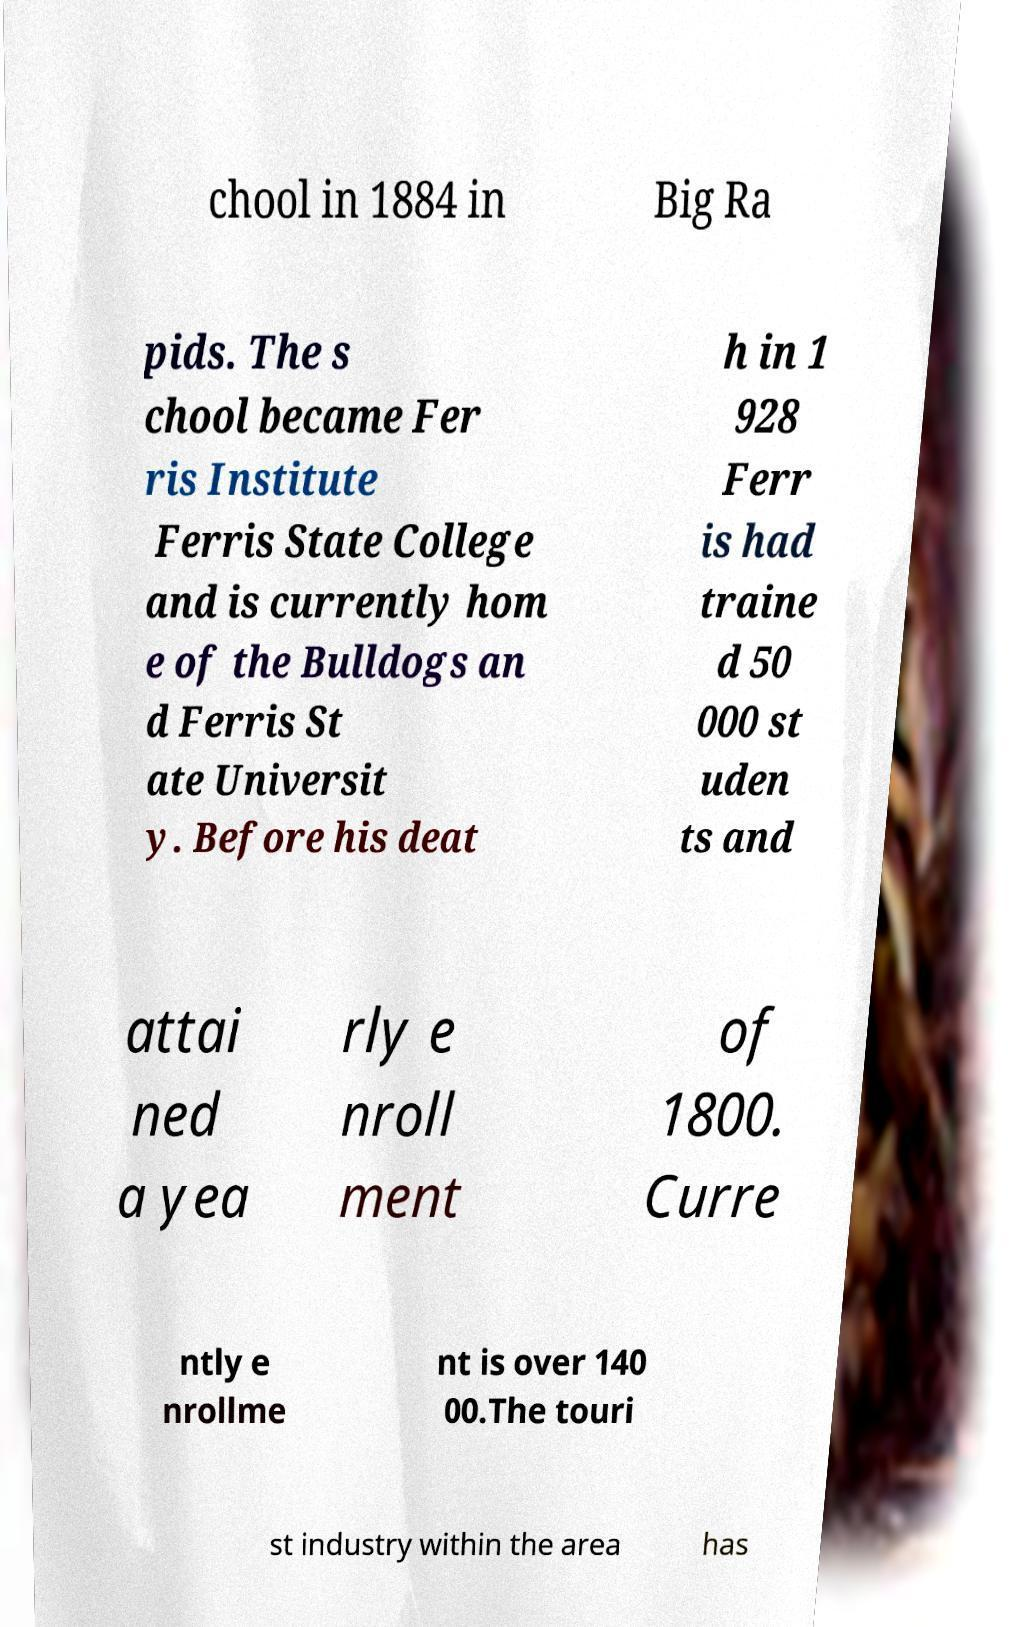Please identify and transcribe the text found in this image. chool in 1884 in Big Ra pids. The s chool became Fer ris Institute Ferris State College and is currently hom e of the Bulldogs an d Ferris St ate Universit y. Before his deat h in 1 928 Ferr is had traine d 50 000 st uden ts and attai ned a yea rly e nroll ment of 1800. Curre ntly e nrollme nt is over 140 00.The touri st industry within the area has 